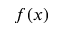Convert formula to latex. <formula><loc_0><loc_0><loc_500><loc_500>f ( x )</formula> 